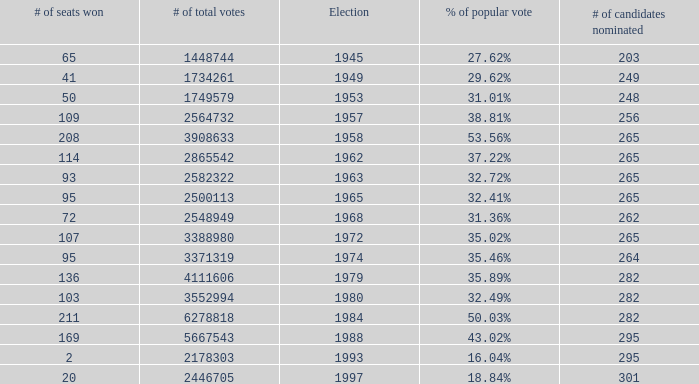What is the election year when the # of candidates nominated was 262? 1.0. 